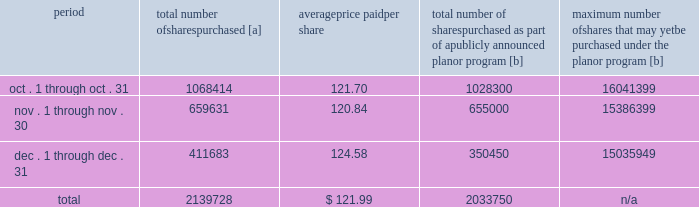Five-year performance comparison 2013 the following graph provides an indicator of cumulative total shareholder returns for the corporation as compared to the peer group index ( described above ) , the dj trans , and the s&p 500 .
The graph assumes that $ 100 was invested in the common stock of union pacific corporation and each index on december 31 , 2007 and that all dividends were reinvested .
Purchases of equity securities 2013 during 2012 , we repurchased 13804709 shares of our common stock at an average price of $ 115.33 .
The table presents common stock repurchases during each month for the fourth quarter of 2012 : period total number of shares purchased [a] average price paid per share total number of shares purchased as part of a publicly announced plan or program [b] maximum number of shares that may yet be purchased under the plan or program [b] .
[a] total number of shares purchased during the quarter includes approximately 105978 shares delivered or attested to upc by employees to pay stock option exercise prices , satisfy excess tax withholding obligations for stock option exercises or vesting of retention units , and pay withholding obligations for vesting of retention shares .
[b] on april 1 , 2011 , our board of directors authorized the repurchase of up to 40 million shares of our common stock by march 31 , 2014 .
These repurchases may be made on the open market or through other transactions .
Our management has sole discretion with respect to determining the timing and amount of these transactions. .
What portion of the 2011 plan repurchases were repurchased in 2012? 
Computations: (13804709 / (40 * 1000000))
Answer: 0.34512. 